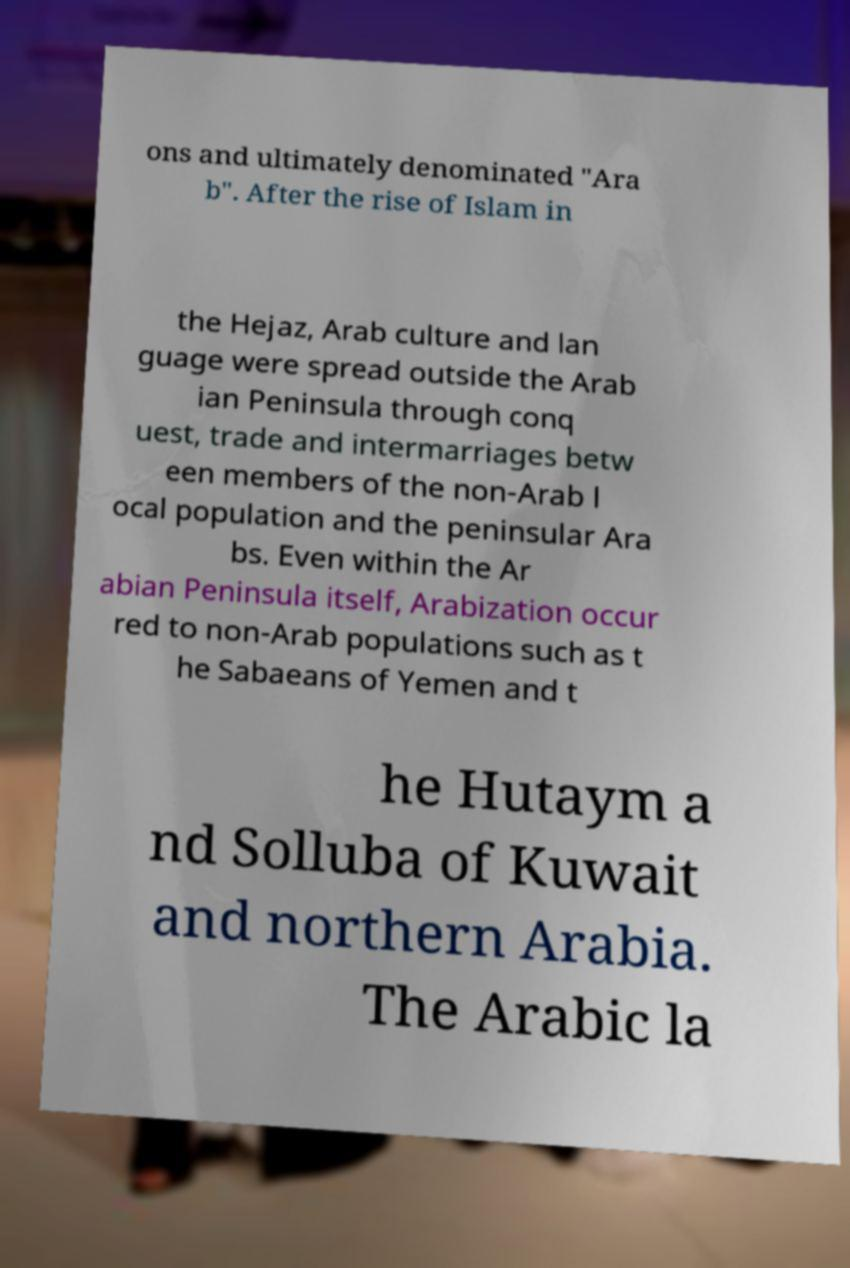Can you accurately transcribe the text from the provided image for me? ons and ultimately denominated "Ara b". After the rise of Islam in the Hejaz, Arab culture and lan guage were spread outside the Arab ian Peninsula through conq uest, trade and intermarriages betw een members of the non-Arab l ocal population and the peninsular Ara bs. Even within the Ar abian Peninsula itself, Arabization occur red to non-Arab populations such as t he Sabaeans of Yemen and t he Hutaym a nd Solluba of Kuwait and northern Arabia. The Arabic la 